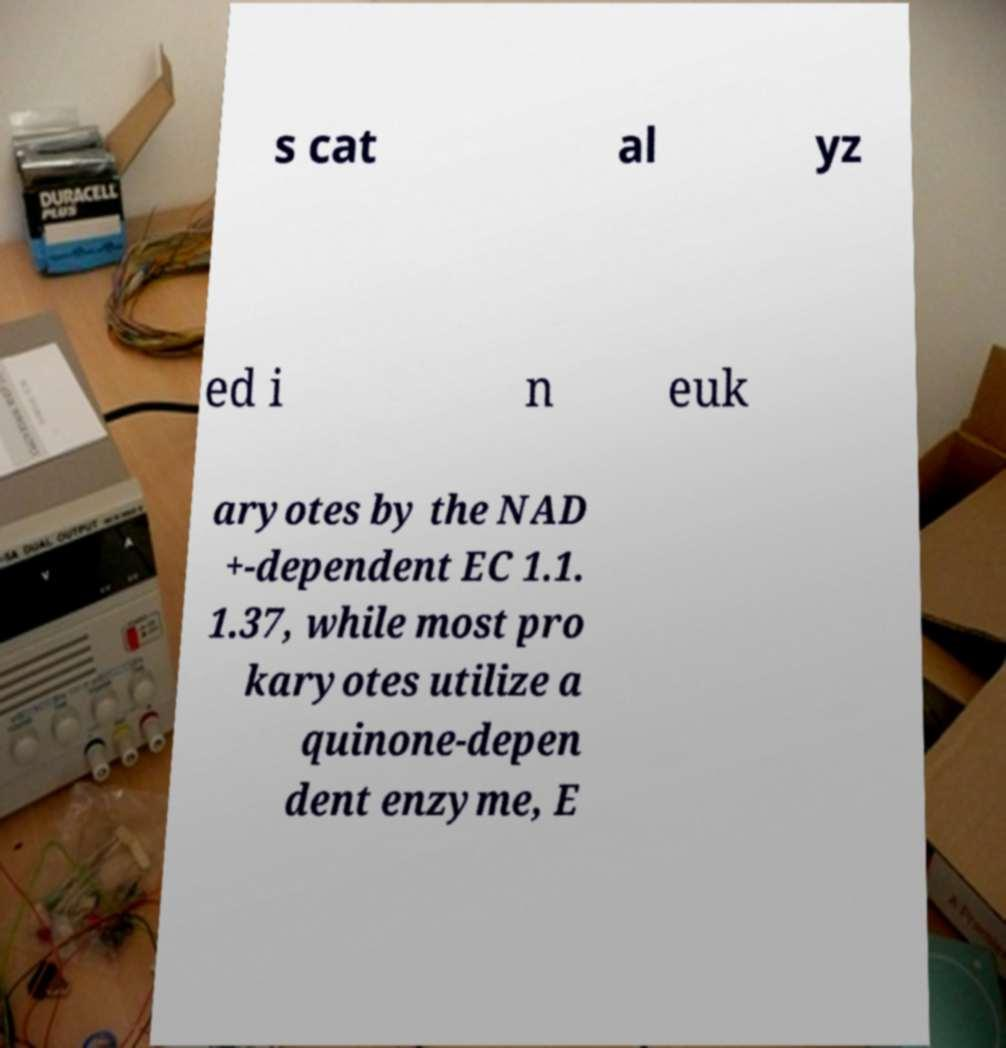Can you read and provide the text displayed in the image?This photo seems to have some interesting text. Can you extract and type it out for me? s cat al yz ed i n euk aryotes by the NAD +-dependent EC 1.1. 1.37, while most pro karyotes utilize a quinone-depen dent enzyme, E 